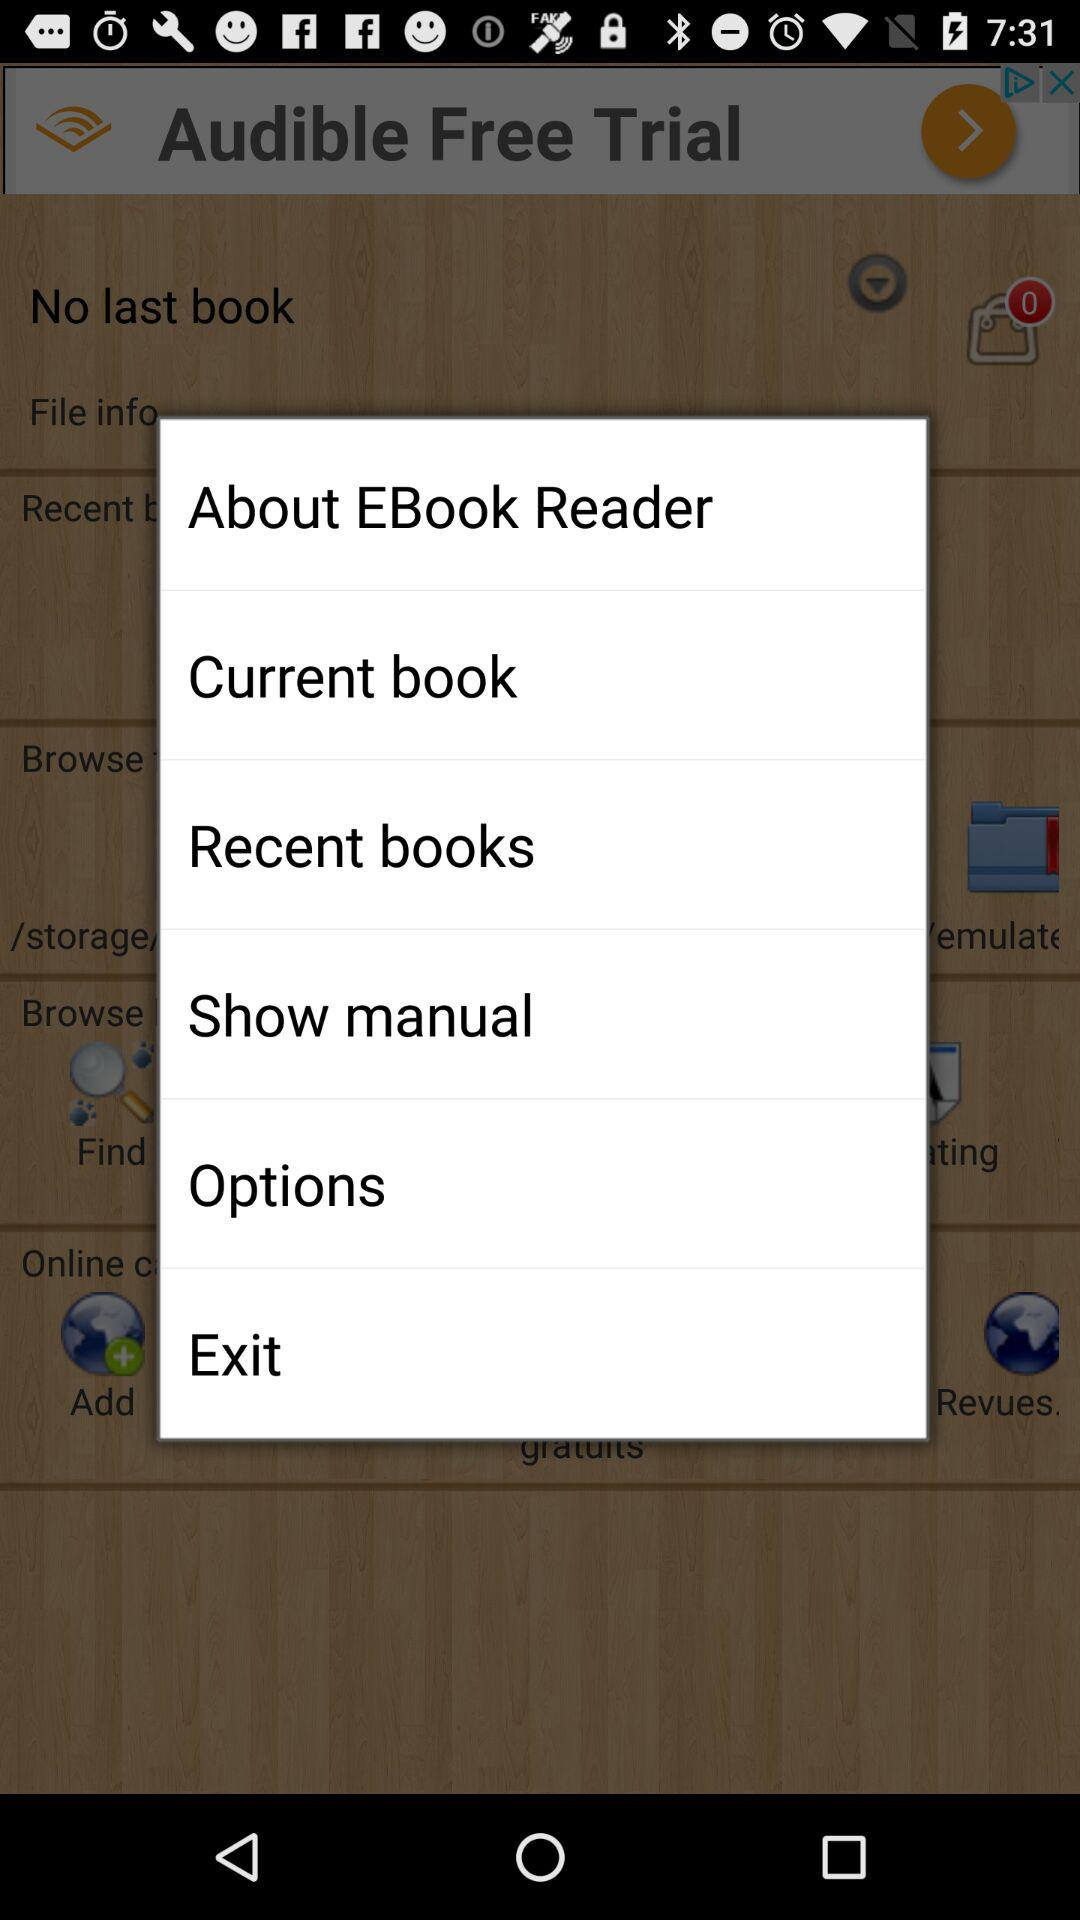What are the options available? The options available are "About EBook Reader", "Current book", "Recent books", "Show manual", "Options", and "Exit". 